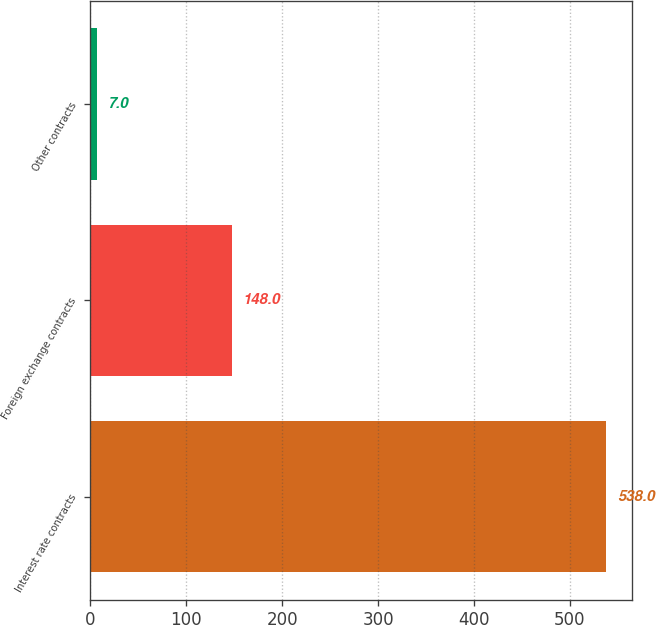Convert chart. <chart><loc_0><loc_0><loc_500><loc_500><bar_chart><fcel>Interest rate contracts<fcel>Foreign exchange contracts<fcel>Other contracts<nl><fcel>538<fcel>148<fcel>7<nl></chart> 